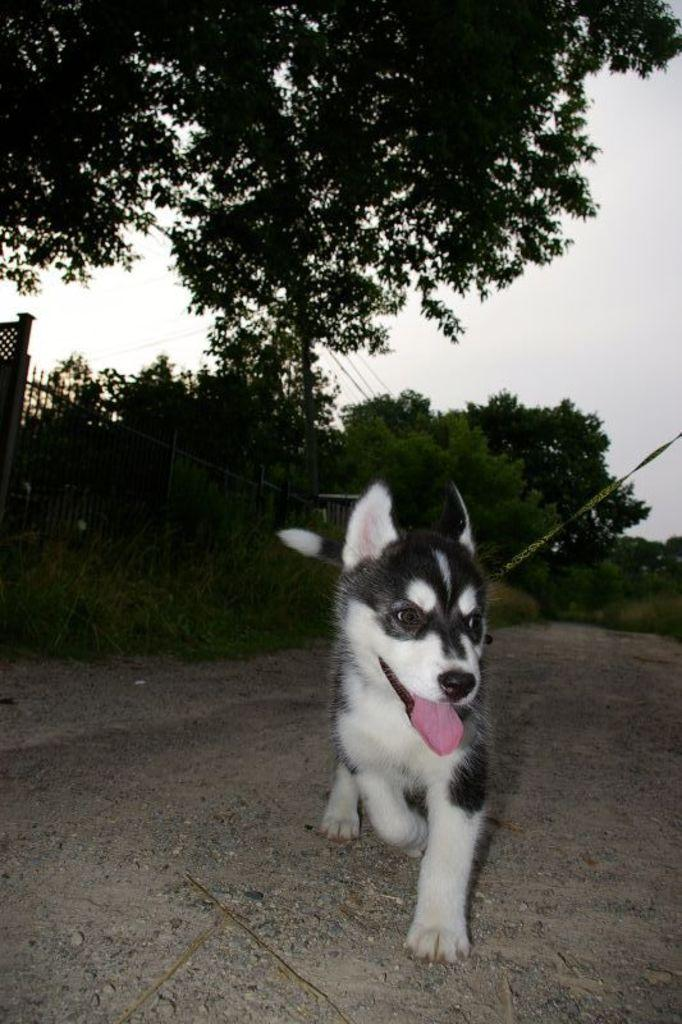What animal can be seen in the image? There is a dog in the image. Where is the dog located? The dog is on a road. What can be seen in the background of the image? There are trees and fencing in the background of the image. How would you describe the sky in the image? The sky is cloudy in the background of the image. What type of disease is the dog suffering from in the image? There is no indication in the image that the dog is suffering from any disease. 